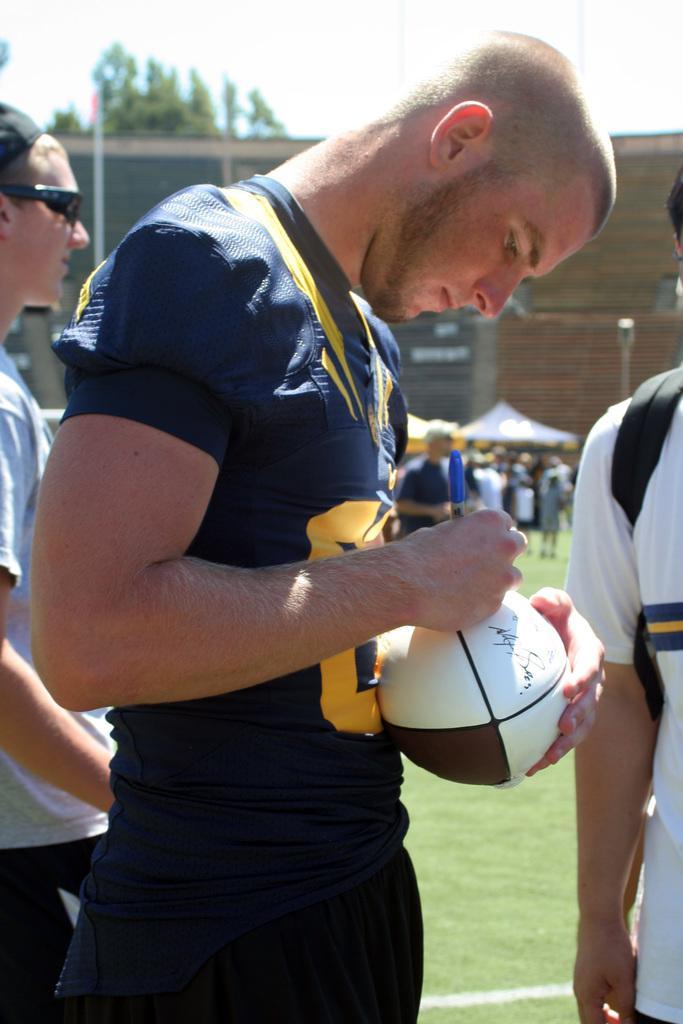Describe this image in one or two sentences. In the middle there is a man he wear black t shirt and trouser ,he is holding a ball he is writing some thing on that ball. On the left there is a person. On the right there is a man he wear white t shirt and bag. In the back ground there are some talents, people ,pole ,wall,tree and sky. 